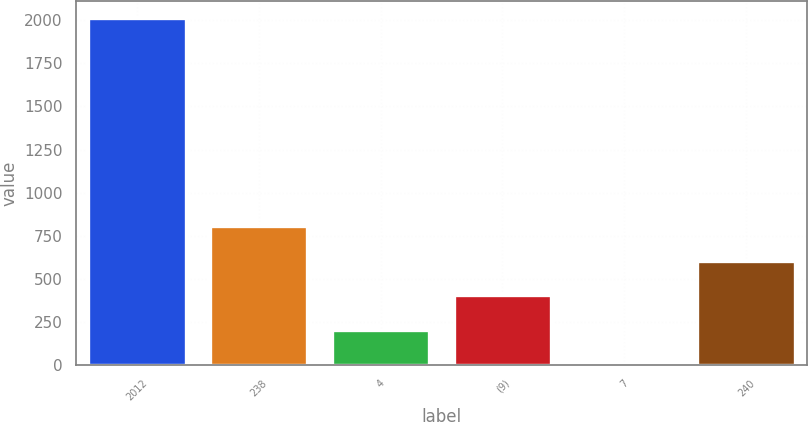Convert chart to OTSL. <chart><loc_0><loc_0><loc_500><loc_500><bar_chart><fcel>2012<fcel>238<fcel>4<fcel>(9)<fcel>7<fcel>240<nl><fcel>2011<fcel>805<fcel>202<fcel>403<fcel>1<fcel>604<nl></chart> 